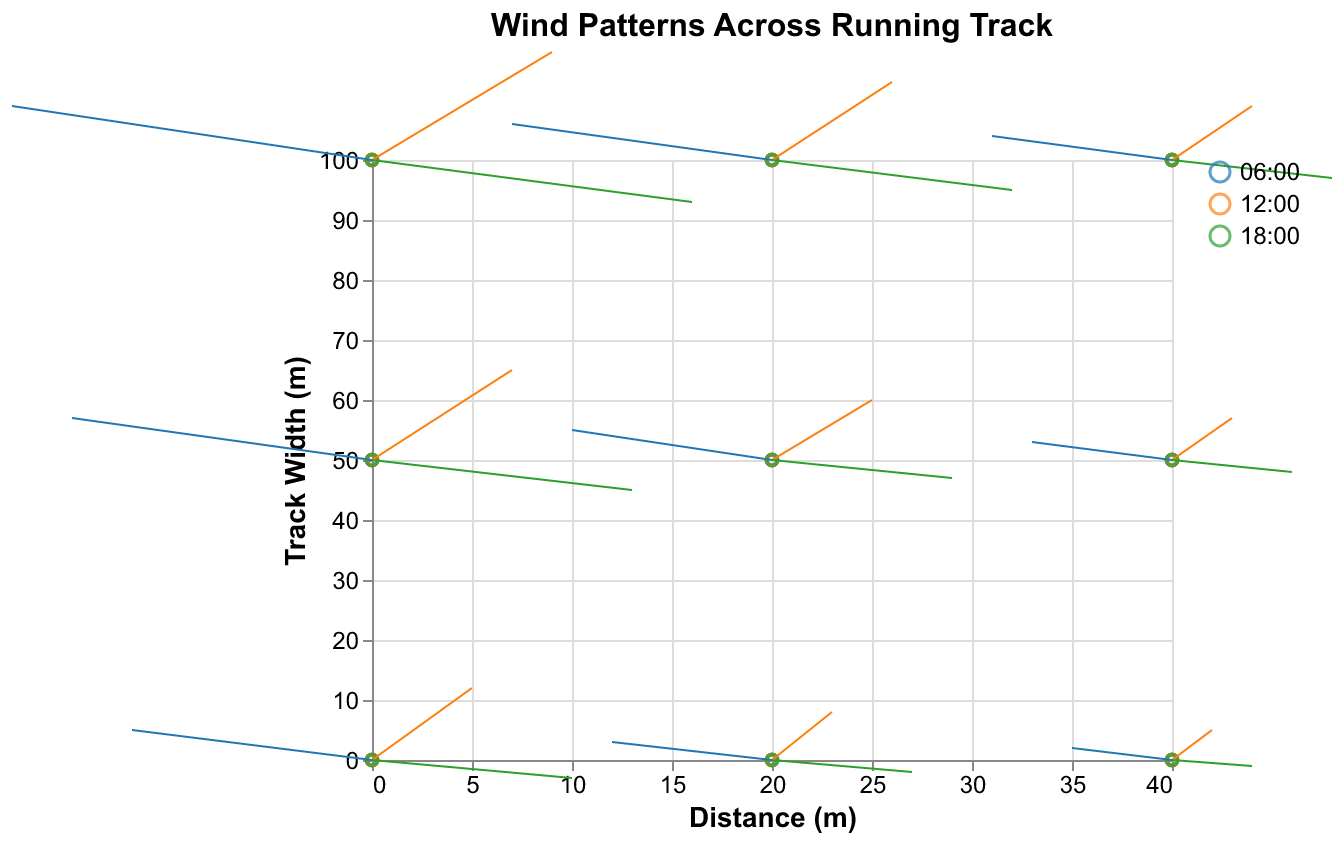What's the title of the figure? The title is usually displayed prominently at the top of the chart. The title of this figure is "Wind Patterns Across Running Track".
Answer: Wind Patterns Across Running Track How many times of day are represented in the plot? By looking at the figure, different colors represent different times of the day. Three distinct colors correspond to three times of the day: 06:00, 12:00, and 18:00.
Answer: 3 Where is the largest horizontal (U) wind component observed at 06:00? The largest horizontal (U) component at 06:00 can be observed by checking the U values for the time 06:00. The maximum U value at this time is -0.5. This occurs at the point (40, 0).
Answer: (40, 0) Which time of day shows the largest vertical (V) wind component? The largest vertical (V) component value can be observed from the vectors in the plot. The maximum V value is 1.8, which occurs at 12:00.
Answer: 12:00 Is there a time of day where the wind direction is mostly downward? Wind direction can be determined by the sign of the V component, where a negative value indicates downward. At 18:00, all V components have negative values, indicating that the wind direction is mostly downward during this time.
Answer: Yes, 18:00 Which point has the highest wind speed at 12:00? Wind speed can be calculated using the formula sqrt(U^2 + V^2). At 12:00, point (0, 100) has U=0.9 and V=1.8. Wind speed is sqrt(0.9^2 + 1.8^2) = 2.012. This is the highest among points at 12:00.
Answer: (0, 100) Compare the average U component at 06:00 and 12:00. Calculate the average U component for each time:
06:00: Sum of U = -1.2 - 0.8 - 0.5 - 1.5 - 1.0 - 0.7 - 1.8 - 1.3 - 0.9 = -9.7, average = -9.7/9 = -1.078.
12:00: Sum of U = 0.5 + 0.3 + 0.2 + 0.7 + 0.5 + 0.3 + 0.9 + 0.6 + 0.4 = 4.4, average = 4.4/9 = 0.489. So, the average U component at 12:00 is higher.
Answer: Higher at 12:00 What is the direction of the wind at point (20, 100) at 18:00? At 18:00, the U component at (20, 100) is 1.2 and V component is -0.5. Therefore, the wind direction is to the right (positive U) and downward (negative V).
Answer: Right and downward How does the wind pattern at point (40, 50) change from 06:00 to 18:00? At 06:00, U=-0.7, V=0.3 (left and upward). At 18:00, U=0.6, V=-0.2 (right and downward). The direction changes from left and upward to right and downward.
Answer: Changes from left and upward to right and downward 